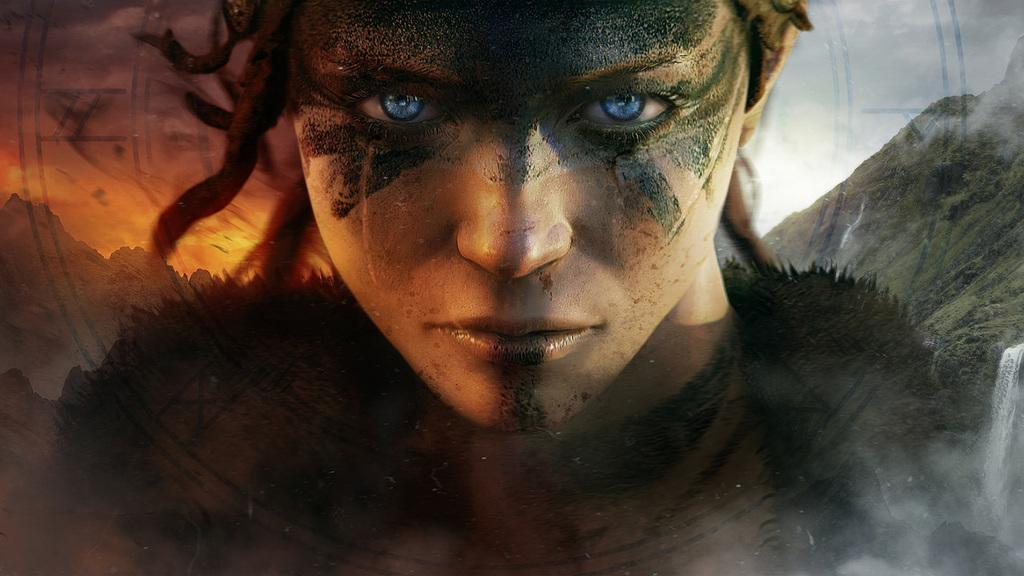What type of image is shown in the picture? The image contains an edited picture of a person. What natural features can be seen in the image? There are mountains and waterfalls in the image. Where are the waterfalls located in the image? The waterfalls are on the right side of the image. What is visible in the background of the image? The sky is visible in the background of the image. What type of power source is visible in the image? There is no power source visible in the image; it contains an edited picture of a person, mountains, waterfalls, and the sky. Can you tell me how many cherries are on the waterfall in the image? There are no cherries present in the image; it features mountains, waterfalls, and the sky. 